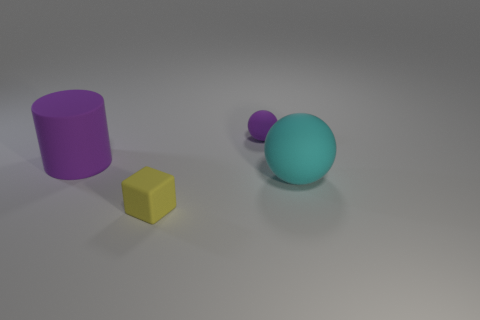There is a tiny rubber object that is in front of the large purple cylinder; what shape is it?
Provide a short and direct response. Cube. There is a small object in front of the large rubber object that is left of the small yellow matte thing; what shape is it?
Make the answer very short. Cube. Are there any tiny rubber things of the same shape as the large cyan matte object?
Your answer should be compact. Yes. There is a purple rubber object that is the same size as the yellow block; what shape is it?
Offer a terse response. Sphere. Are there any purple cylinders to the left of the purple object that is behind the large object left of the large cyan sphere?
Keep it short and to the point. Yes. Is there a purple cylinder of the same size as the cyan object?
Make the answer very short. Yes. There is a thing that is right of the small purple thing; what is its size?
Keep it short and to the point. Large. There is a large object on the right side of the purple rubber object that is on the left side of the purple object that is behind the big cylinder; what color is it?
Give a very brief answer. Cyan. The small thing in front of the ball right of the tiny purple thing is what color?
Your answer should be very brief. Yellow. Is the number of tiny rubber blocks that are behind the yellow matte cube greater than the number of cyan spheres to the left of the small sphere?
Provide a succinct answer. No. 